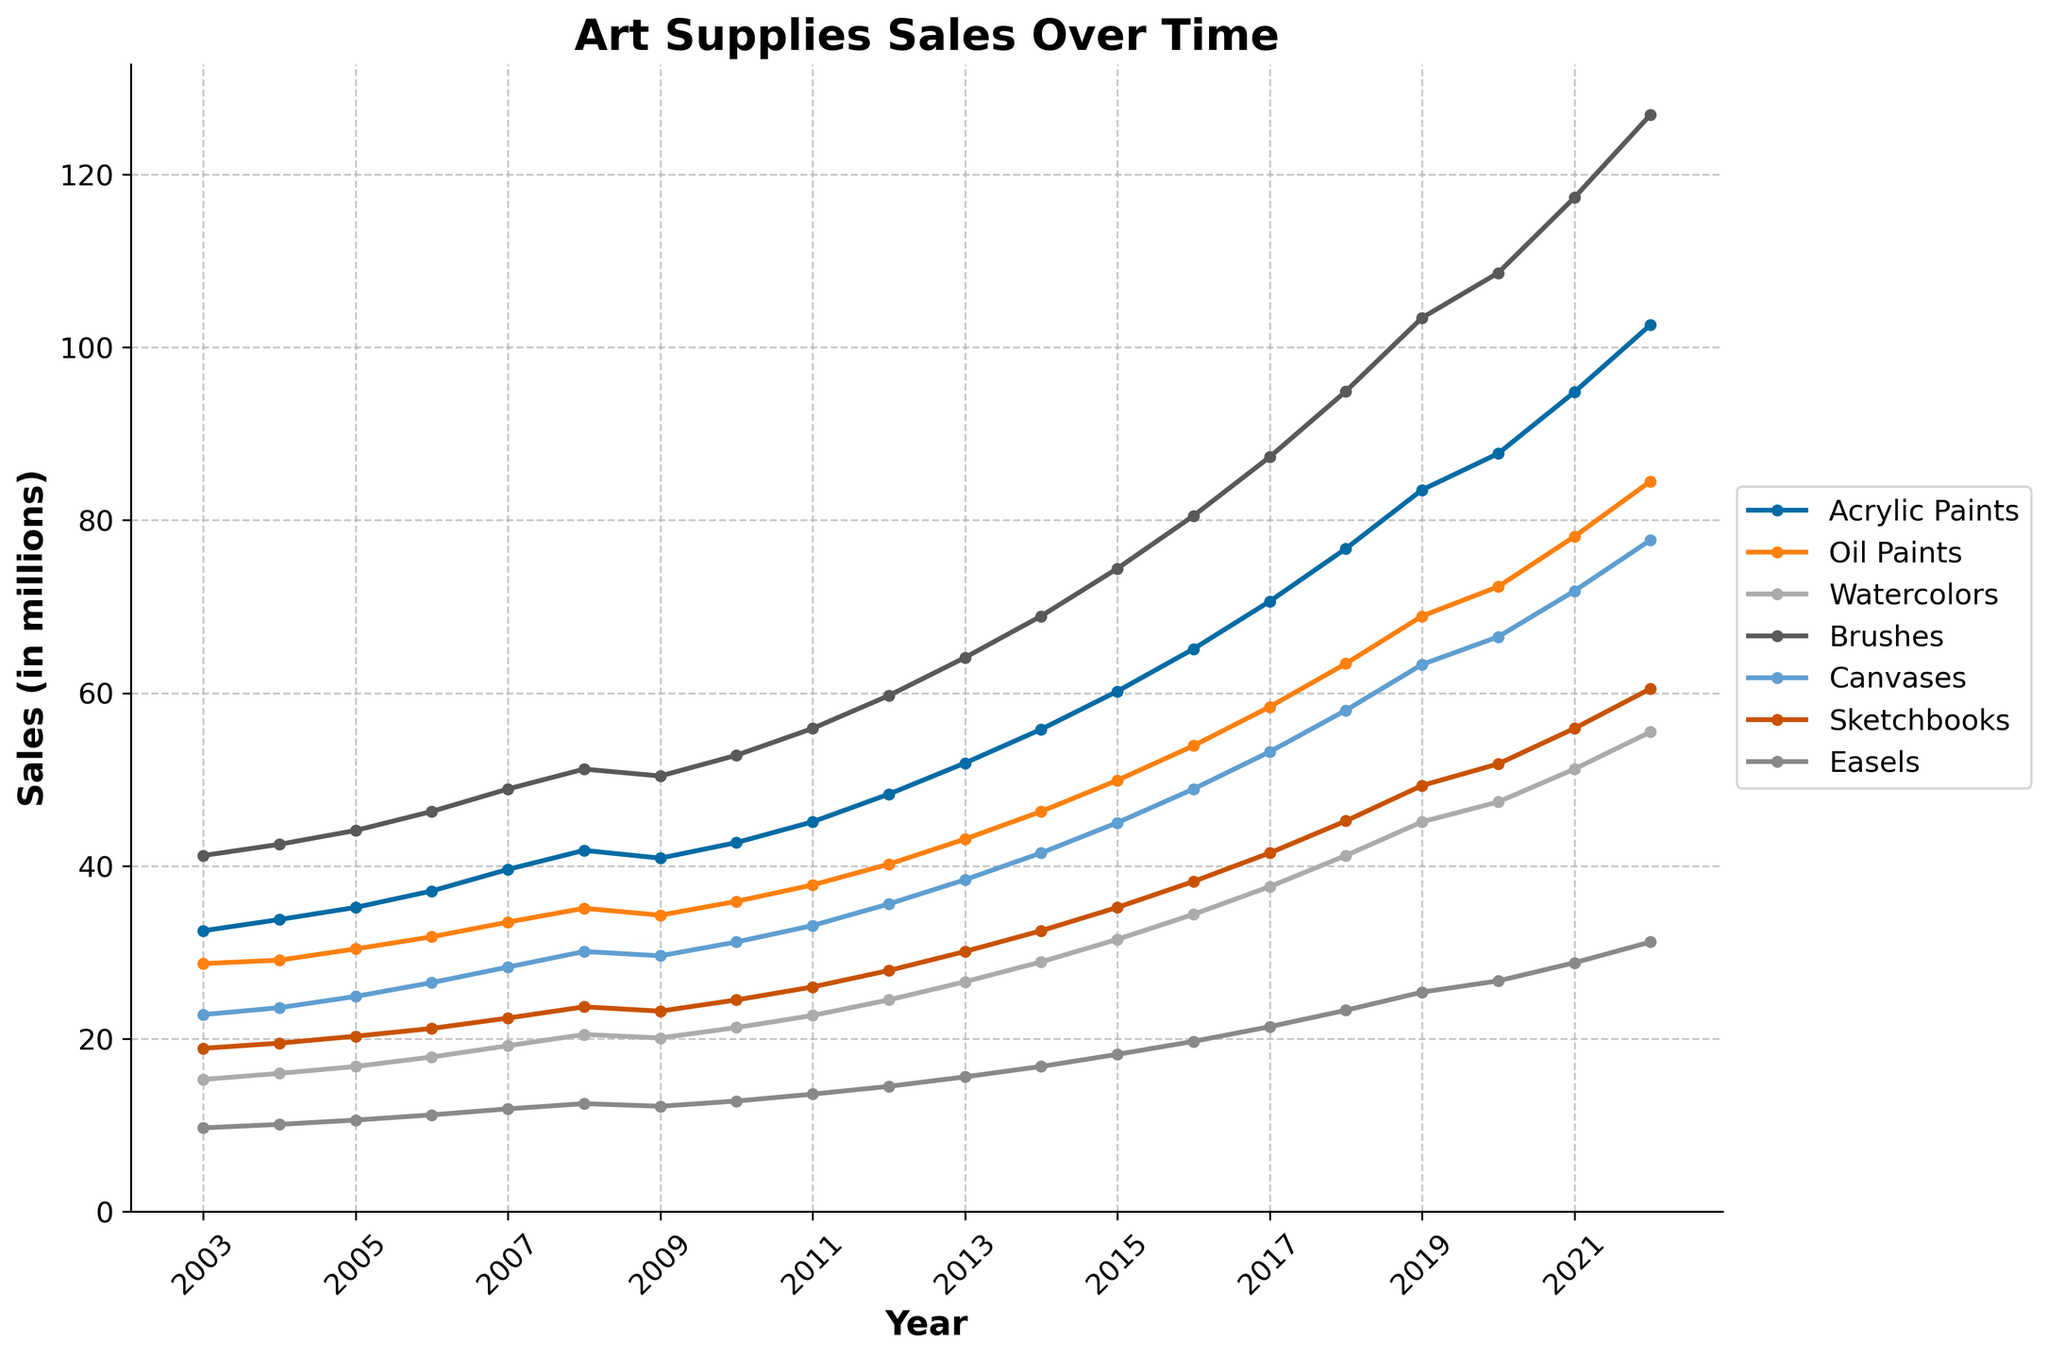What's the category with the highest sales in 2022? The highest point on the graph in 2022 is associated with the "Brushes" category.
Answer: Brushes Which category had the lowest sales in 2003? By comparing the values for all categories in 2003, Easels have the lowest sales figure.
Answer: Easels What is the average annual sales for Oil Paints over the two decades? Sum the sales figures for Oil Paints from 2003 to 2022 and divide by the total number of years: (28.7 + 29.1 + 30.4 + 31.8 + 33.5 + 35.1 + 34.3 + 35.9 + 37.8 + 40.2 + 43.1 + 46.3 + 49.9 + 53.9 + 58.4 + 63.4 + 68.9 + 72.3 + 78.1 + 84.5) / 20 ≈ 47.79
Answer: 47.79 Compare the sales trend of Acrylic Paints and Watercolors. Which one grew faster? By examining the slope of the lines for Acrylic Paints and Watercolors, Acrylic Paints showed a steeper increase over the years, indicating faster growth.
Answer: Acrylic Paints In which year did Sketchbooks hit $30 million in sales? The figure shows that Sketchbooks hit $30 million in sales in 2013.
Answer: 2013 Which two categories had the most similar sales figures in 2010? In 2010, Easels and Sketchbooks had very similar sales figures, both being close to each other.
Answer: Easels and Sketchbooks Calculate the total sales for all categories combined in 2015. Sum the sales figures for all categories in 2015: 60.2 (Acrylic Paints) + 49.9 (Oil Paints) + 31.5 (Watercolors) + 74.4 (Brushes) + 45.0 (Canvases) + 35.2 (Sketchbooks) + 18.2 (Easels) = 314.4 million
Answer: 314.4 million Which category saw the biggest increase in sales from 2007 to 2022? By calculating the difference in sales figures for each category from 2007 to 2022, Brushes increased the most: 126.9 - 48.9 = 78.0 million
Answer: Brushes What are the categories where sales never declined over the two decades? By observing the lines, Acrylic Paints, Oil Paints, Watercolors, and Easels show a continual increase without any decline.
Answer: Acrylic Paints, Oil Paints, Watercolors, Easels 